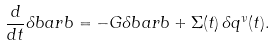Convert formula to latex. <formula><loc_0><loc_0><loc_500><loc_500>\frac { d } { d t } \delta b a r b = - G \delta b a r b + \Sigma ( t ) \, \delta q ^ { \nu } ( t ) .</formula> 